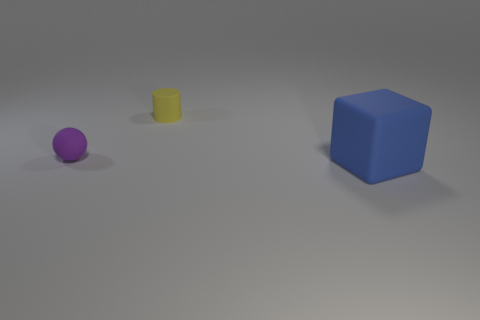Can you describe the colors of the objects starting from the smallest to the largest? Certainly! The smallest object is a purple sphere, followed by a yellow cylinder, and the largest object is a blue cube. 